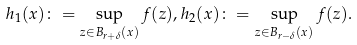Convert formula to latex. <formula><loc_0><loc_0><loc_500><loc_500>h _ { 1 } ( x ) \colon = \sup _ { z \in B _ { r + \delta } ( x ) } f ( z ) , h _ { 2 } ( x ) \colon = \sup _ { z \in B _ { r - \delta } ( x ) } f ( z ) .</formula> 